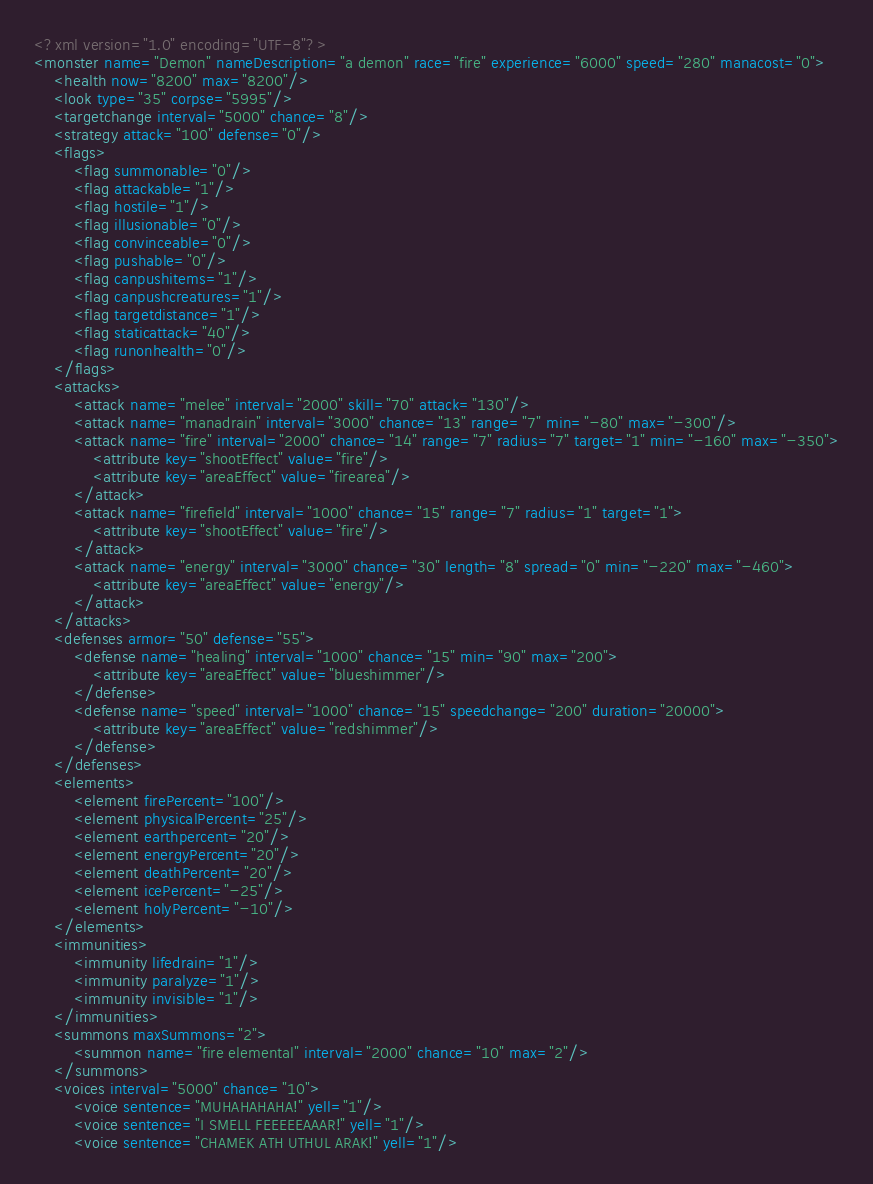Convert code to text. <code><loc_0><loc_0><loc_500><loc_500><_XML_><?xml version="1.0" encoding="UTF-8"?>
<monster name="Demon" nameDescription="a demon" race="fire" experience="6000" speed="280" manacost="0">
	<health now="8200" max="8200"/>
	<look type="35" corpse="5995"/>
	<targetchange interval="5000" chance="8"/>
	<strategy attack="100" defense="0"/>
	<flags>
		<flag summonable="0"/>
		<flag attackable="1"/>
		<flag hostile="1"/>
		<flag illusionable="0"/>
		<flag convinceable="0"/>
		<flag pushable="0"/>
		<flag canpushitems="1"/>
		<flag canpushcreatures="1"/>
		<flag targetdistance="1"/>
		<flag staticattack="40"/>
		<flag runonhealth="0"/>
	</flags>
	<attacks>
		<attack name="melee" interval="2000" skill="70" attack="130"/>
		<attack name="manadrain" interval="3000" chance="13" range="7" min="-80" max="-300"/>
		<attack name="fire" interval="2000" chance="14" range="7" radius="7" target="1" min="-160" max="-350">
			<attribute key="shootEffect" value="fire"/>
			<attribute key="areaEffect" value="firearea"/>
		</attack>
		<attack name="firefield" interval="1000" chance="15" range="7" radius="1" target="1">
			<attribute key="shootEffect" value="fire"/>
		</attack>
		<attack name="energy" interval="3000" chance="30" length="8" spread="0" min="-220" max="-460">
			<attribute key="areaEffect" value="energy"/>
		</attack>
	</attacks>
	<defenses armor="50" defense="55">
		<defense name="healing" interval="1000" chance="15" min="90" max="200">
			<attribute key="areaEffect" value="blueshimmer"/>
		</defense>
		<defense name="speed" interval="1000" chance="15" speedchange="200" duration="20000">
			<attribute key="areaEffect" value="redshimmer"/>
		</defense>
	</defenses>
	<elements>
		<element firePercent="100"/>
		<element physicalPercent="25"/>
		<element earthpercent="20"/>
		<element energyPercent="20"/>
		<element deathPercent="20"/>
		<element icePercent="-25"/>
		<element holyPercent="-10"/>
	</elements>
	<immunities>
		<immunity lifedrain="1"/>
		<immunity paralyze="1"/>
		<immunity invisible="1"/>
	</immunities>
	<summons maxSummons="2">
		<summon name="fire elemental" interval="2000" chance="10" max="2"/>
	</summons>
	<voices interval="5000" chance="10">
		<voice sentence="MUHAHAHAHA!" yell="1"/>
		<voice sentence="I SMELL FEEEEEAAAR!" yell="1"/>
		<voice sentence="CHAMEK ATH UTHUL ARAK!" yell="1"/></code> 